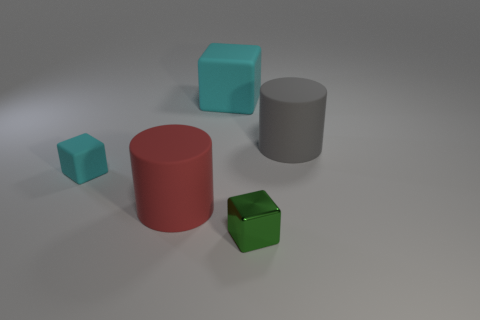There is a cylinder in front of the large gray rubber cylinder; what is its size?
Your answer should be very brief. Large. How many small rubber objects are the same color as the metal cube?
Offer a terse response. 0. How many balls are either gray matte things or tiny objects?
Your answer should be compact. 0. There is a big object that is behind the big red matte thing and to the left of the metal thing; what is its shape?
Provide a short and direct response. Cube. Are there any other red metallic cylinders of the same size as the red cylinder?
Ensure brevity in your answer.  No. How many objects are either cyan cubes behind the big gray cylinder or metallic blocks?
Your response must be concise. 2. Is the gray thing made of the same material as the tiny thing that is right of the red rubber thing?
Your answer should be compact. No. How many other objects are there of the same shape as the small shiny object?
Ensure brevity in your answer.  2. How many objects are cylinders right of the large red matte thing or big matte objects right of the small green thing?
Offer a very short reply. 1. What number of other things are the same color as the large rubber cube?
Ensure brevity in your answer.  1. 